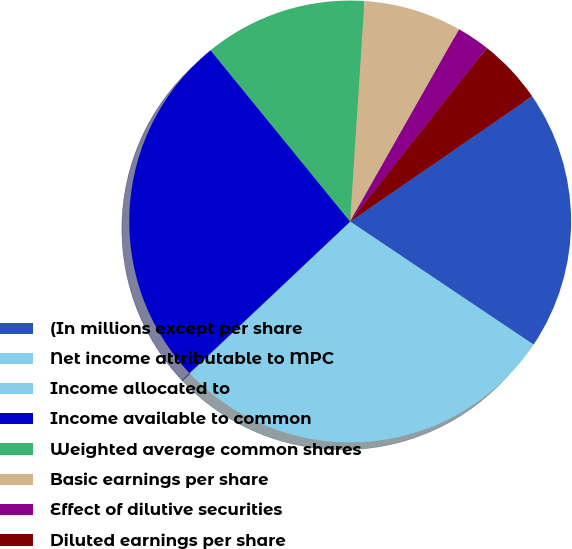Convert chart to OTSL. <chart><loc_0><loc_0><loc_500><loc_500><pie_chart><fcel>(In millions except per share<fcel>Net income attributable to MPC<fcel>Income allocated to<fcel>Income available to common<fcel>Weighted average common shares<fcel>Basic earnings per share<fcel>Effect of dilutive securities<fcel>Diluted earnings per share<nl><fcel>19.0%<fcel>28.52%<fcel>0.04%<fcel>26.15%<fcel>11.92%<fcel>7.17%<fcel>2.41%<fcel>4.79%<nl></chart> 